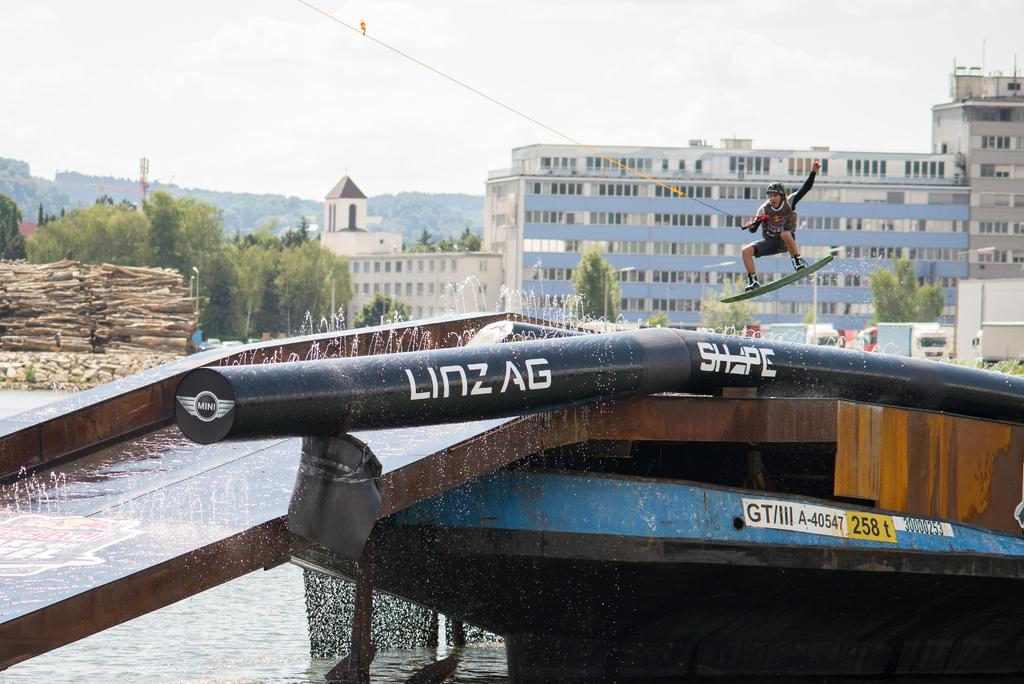<image>
Relay a brief, clear account of the picture shown. Sign on a boat which says 258t in yellow. 